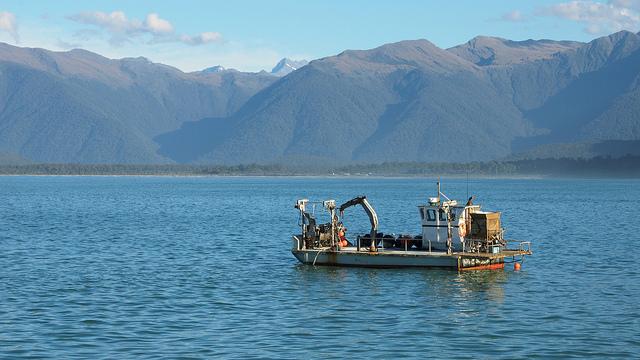Is this a fishing vessel?
Short answer required. No. Is the sky shown in this picture?
Answer briefly. Yes. Do you see any humans on the boat?
Answer briefly. No. 